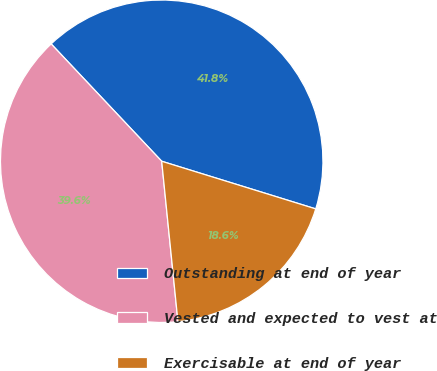<chart> <loc_0><loc_0><loc_500><loc_500><pie_chart><fcel>Outstanding at end of year<fcel>Vested and expected to vest at<fcel>Exercisable at end of year<nl><fcel>41.8%<fcel>39.58%<fcel>18.62%<nl></chart> 